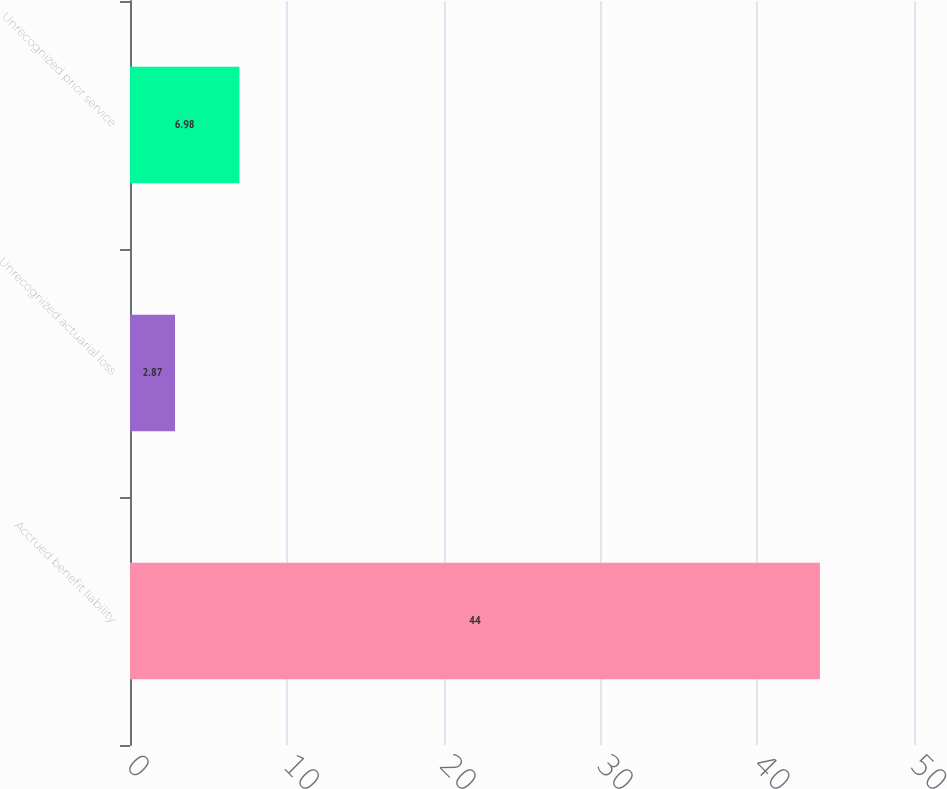Convert chart. <chart><loc_0><loc_0><loc_500><loc_500><bar_chart><fcel>Accrued benefit liability<fcel>Unrecognized actuarial loss<fcel>Unrecognized prior service<nl><fcel>44<fcel>2.87<fcel>6.98<nl></chart> 